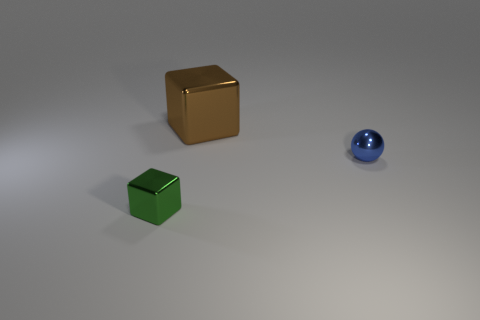Add 2 small green things. How many objects exist? 5 Subtract all spheres. How many objects are left? 2 Subtract all green metallic cylinders. Subtract all large shiny cubes. How many objects are left? 2 Add 1 brown metal objects. How many brown metal objects are left? 2 Add 1 tiny blue balls. How many tiny blue balls exist? 2 Subtract 0 gray cylinders. How many objects are left? 3 